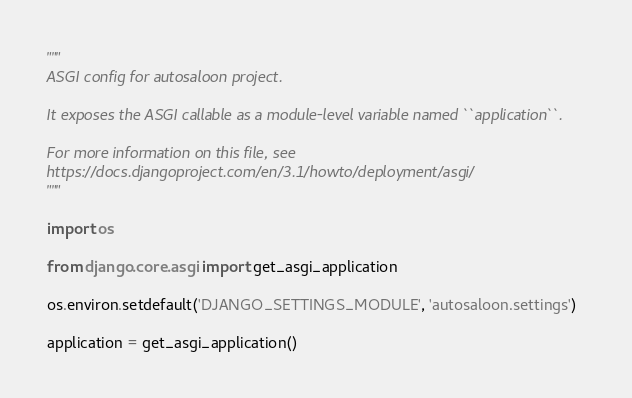Convert code to text. <code><loc_0><loc_0><loc_500><loc_500><_Python_>"""
ASGI config for autosaloon project.

It exposes the ASGI callable as a module-level variable named ``application``.

For more information on this file, see
https://docs.djangoproject.com/en/3.1/howto/deployment/asgi/
"""

import os

from django.core.asgi import get_asgi_application

os.environ.setdefault('DJANGO_SETTINGS_MODULE', 'autosaloon.settings')

application = get_asgi_application()
</code> 